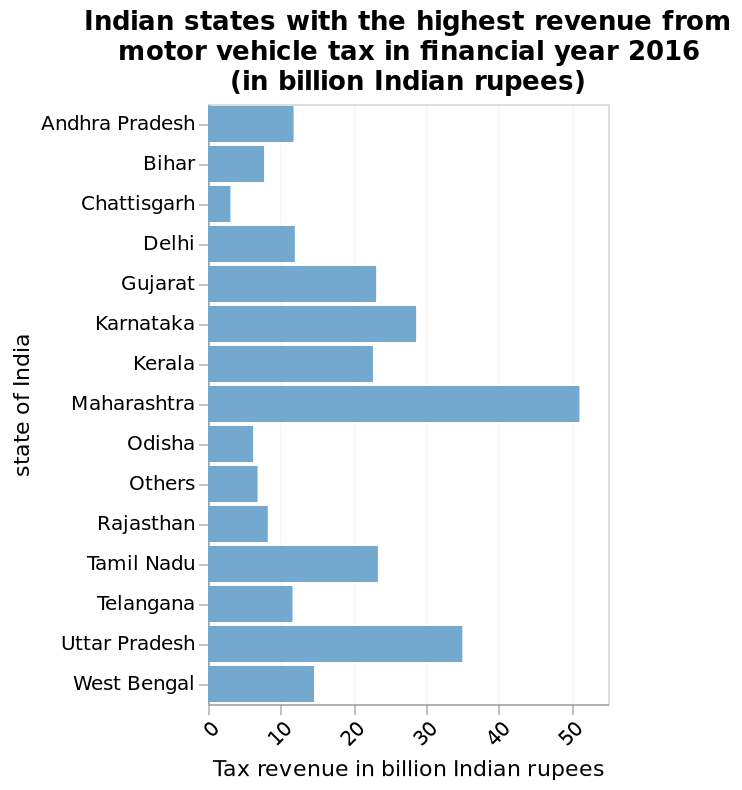<image>
What is the starting and ending point on the y-axis of the bar graph? The y-axis of the bar graph starts at Andhra Pradesh and ends at West Bengal, representing the states of India in between. What type of scale is used for the x-axis in the bar graph? The x-axis of the bar graph uses a linear scale to measure tax revenue in billion Indian rupees. What is the range of the x-axis in the bar graph?  The range of the x-axis in the bar graph is from 0 to 50 billion Indian rupees. Is Maharashtra the only state in India that generates income from motor vehicle tax? The description does not provide information about other states' income from motor vehicle tax. 